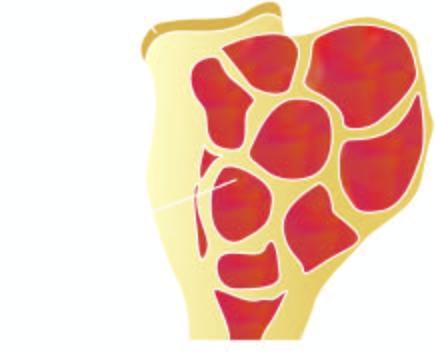s section from margin of amoebic ulcer expanded in the region of epiphysis?
Answer the question using a single word or phrase. No 